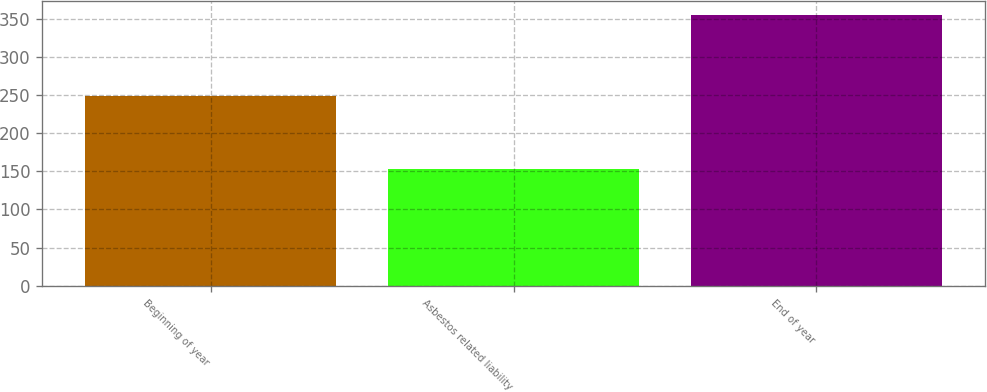<chart> <loc_0><loc_0><loc_500><loc_500><bar_chart><fcel>Beginning of year<fcel>Asbestos related liability<fcel>End of year<nl><fcel>249<fcel>153<fcel>355<nl></chart> 